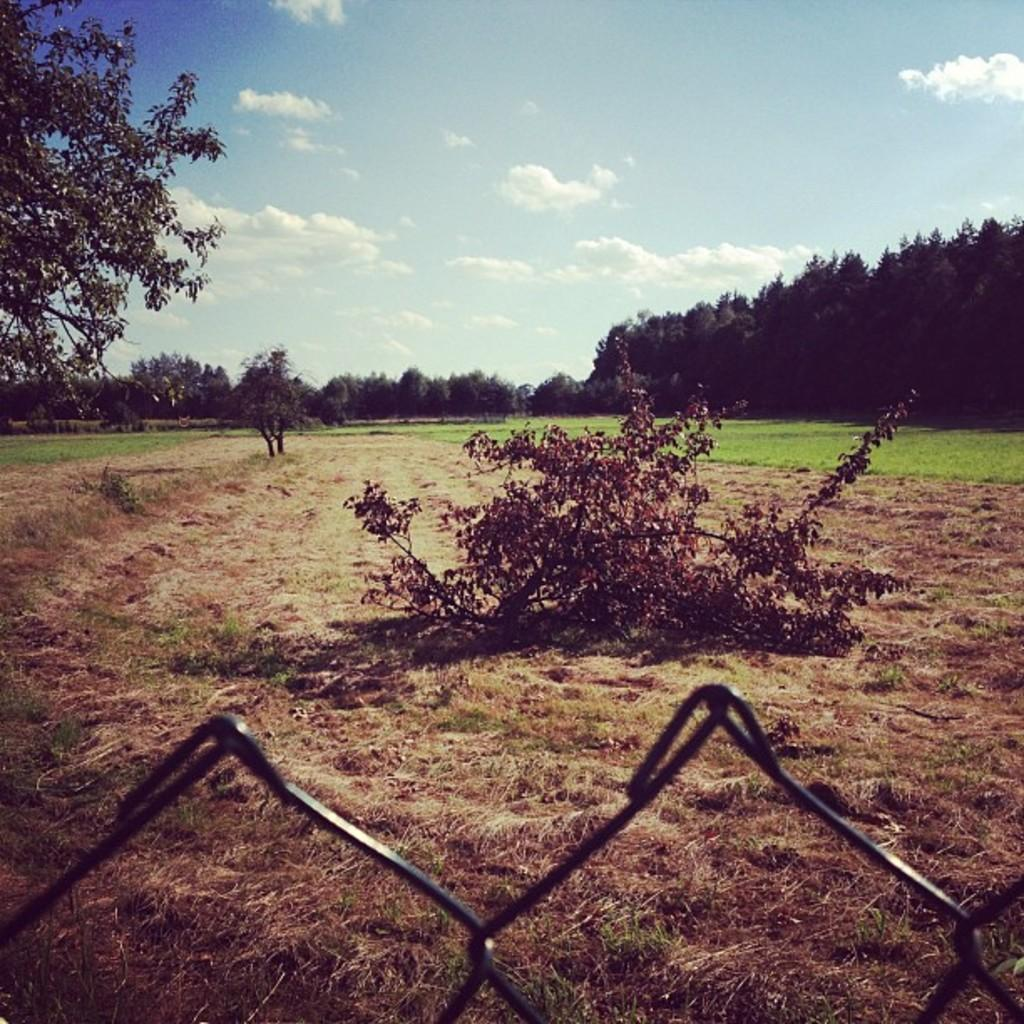What type of vegetation can be seen in the image? There are trees and grass in the image. What type of barrier is present in the image? There is fencing in the image. What is the condition of the sky in the image? The sky is cloudy in the image. Where is the hen located in the image? There is no hen present in the image. 